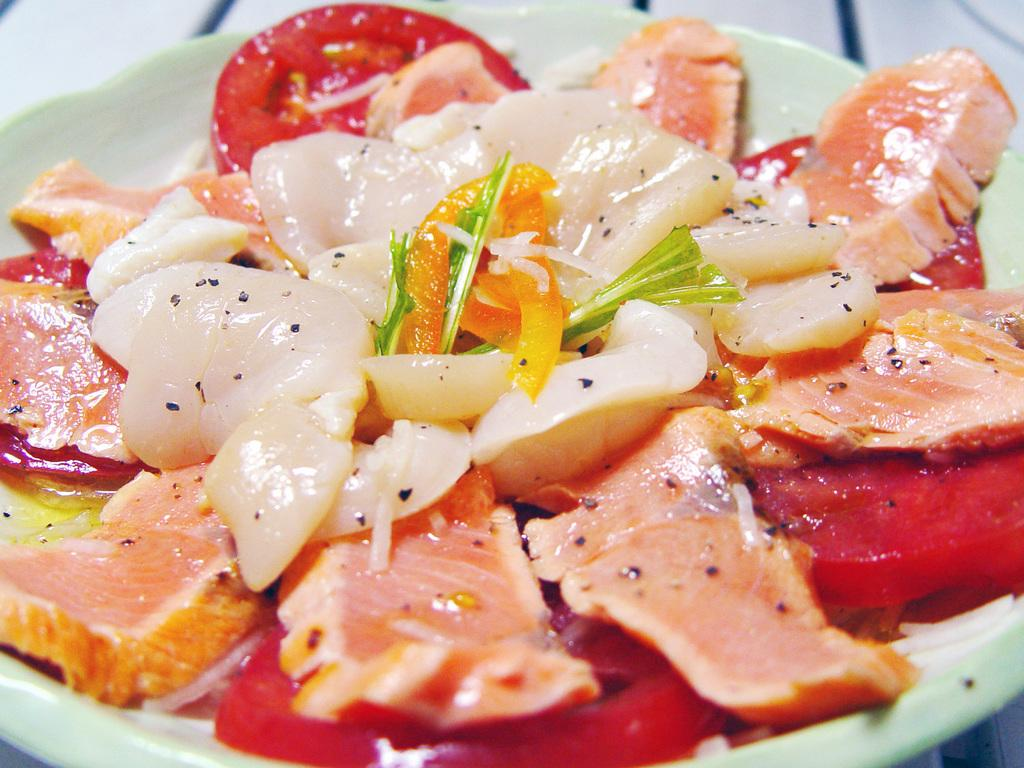What is the main subject of the image? There is a food item on a plate in the image. Can you describe the background of the image? The background of the image is blurred. What type of corn is being copied by the doctor in the image? There is no corn or doctor present in the image. 